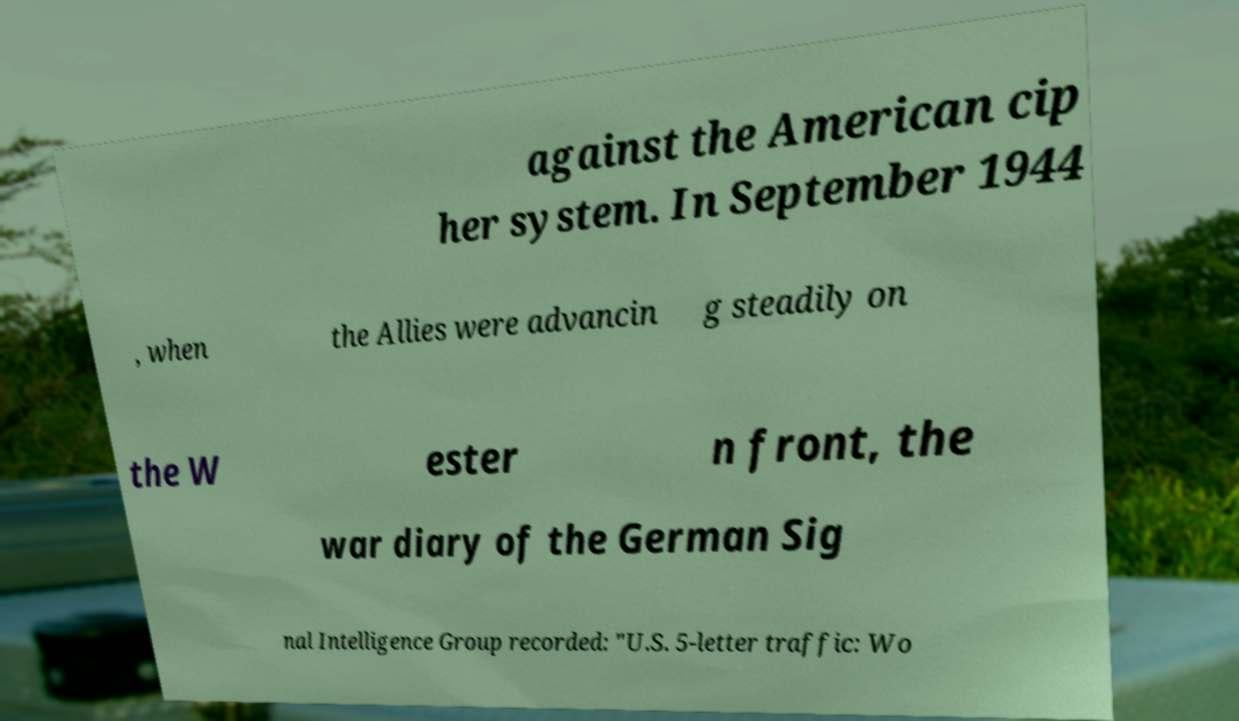I need the written content from this picture converted into text. Can you do that? against the American cip her system. In September 1944 , when the Allies were advancin g steadily on the W ester n front, the war diary of the German Sig nal Intelligence Group recorded: "U.S. 5-letter traffic: Wo 